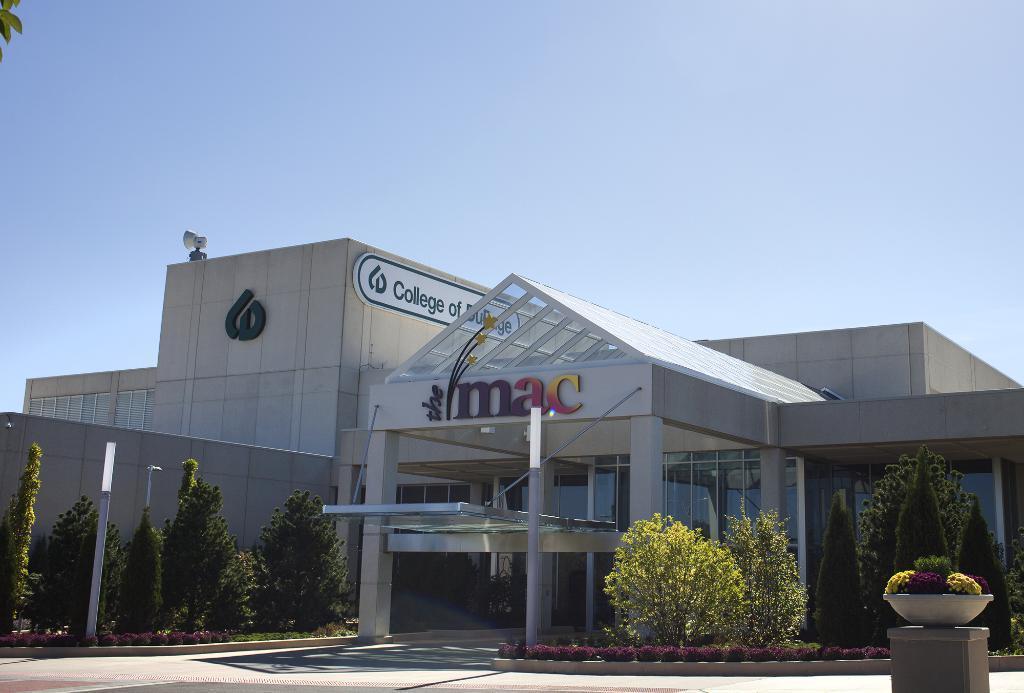Describe this image in one or two sentences. In this image we can see a building with windows, roof, a logo and a sign board. We can also see a group of trees, plants and a pole. On the backside we can see the sky which looks cloudy. 